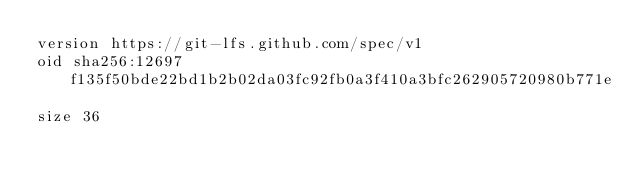Convert code to text. <code><loc_0><loc_0><loc_500><loc_500><_SQL_>version https://git-lfs.github.com/spec/v1
oid sha256:12697f135f50bde22bd1b2b02da03fc92fb0a3f410a3bfc262905720980b771e
size 36
</code> 